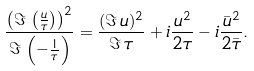<formula> <loc_0><loc_0><loc_500><loc_500>\frac { \left ( \Im \, \left ( \frac { u } { \tau } \right ) \right ) ^ { 2 } } { \Im \, \left ( - \frac { 1 } { \tau } \right ) } = \frac { ( \Im \, u ) ^ { 2 } } { \Im \, \tau } + i \frac { u ^ { 2 } } { 2 \tau } - i \frac { \bar { u } ^ { 2 } } { 2 \bar { \tau } } .</formula> 